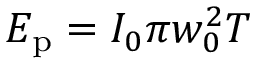Convert formula to latex. <formula><loc_0><loc_0><loc_500><loc_500>E _ { p } = I _ { 0 } { \pi w _ { 0 } ^ { 2 } T }</formula> 